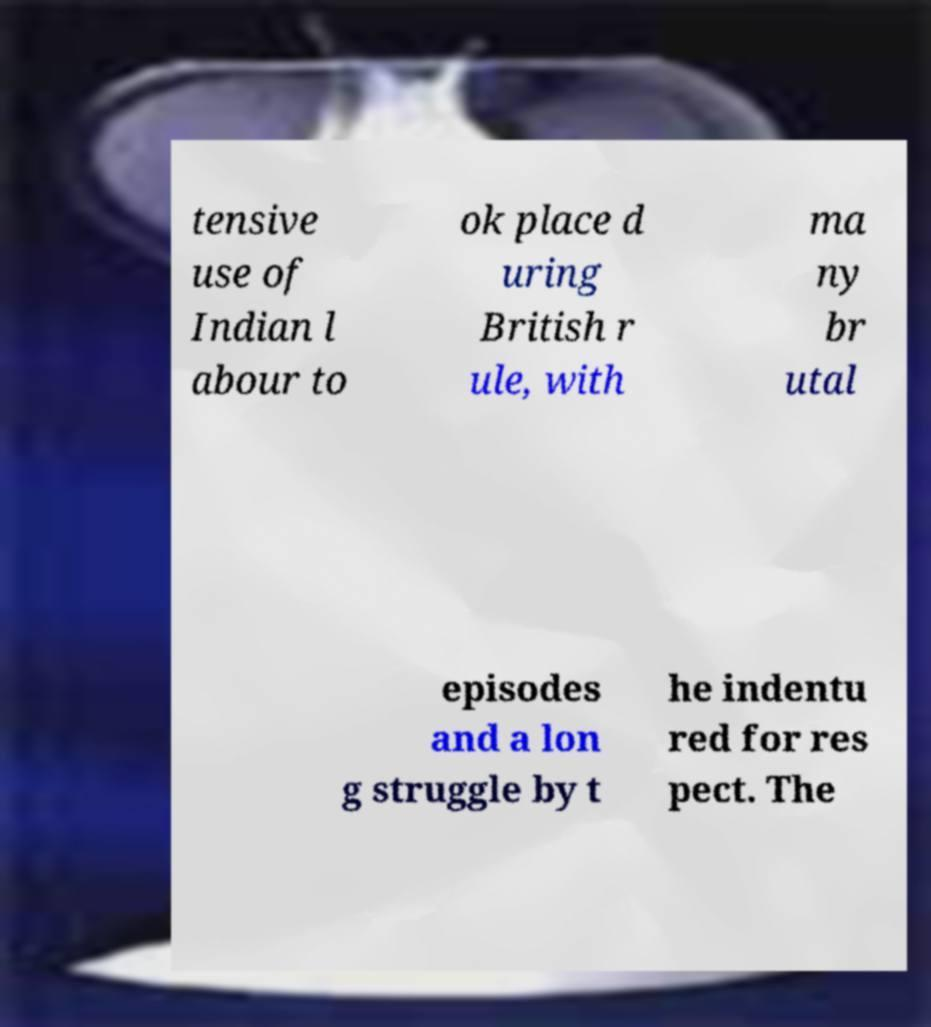For documentation purposes, I need the text within this image transcribed. Could you provide that? tensive use of Indian l abour to ok place d uring British r ule, with ma ny br utal episodes and a lon g struggle by t he indentu red for res pect. The 